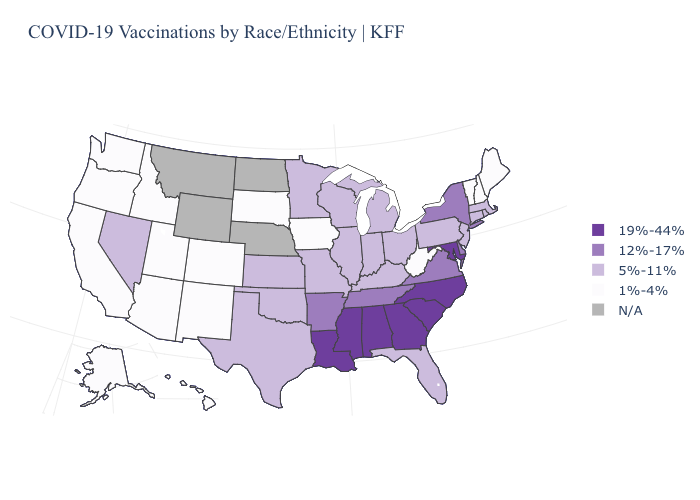What is the value of Washington?
Keep it brief. 1%-4%. What is the value of Colorado?
Concise answer only. 1%-4%. Among the states that border Iowa , does Minnesota have the lowest value?
Keep it brief. No. What is the value of Idaho?
Give a very brief answer. 1%-4%. Among the states that border Arkansas , does Missouri have the lowest value?
Write a very short answer. Yes. What is the lowest value in the Northeast?
Give a very brief answer. 1%-4%. Which states have the lowest value in the USA?
Keep it brief. Alaska, Arizona, California, Colorado, Hawaii, Idaho, Iowa, Maine, New Hampshire, New Mexico, Oregon, South Dakota, Utah, Vermont, Washington, West Virginia. Name the states that have a value in the range 1%-4%?
Short answer required. Alaska, Arizona, California, Colorado, Hawaii, Idaho, Iowa, Maine, New Hampshire, New Mexico, Oregon, South Dakota, Utah, Vermont, Washington, West Virginia. What is the value of Wisconsin?
Quick response, please. 5%-11%. What is the value of Virginia?
Quick response, please. 12%-17%. Which states have the lowest value in the USA?
Give a very brief answer. Alaska, Arizona, California, Colorado, Hawaii, Idaho, Iowa, Maine, New Hampshire, New Mexico, Oregon, South Dakota, Utah, Vermont, Washington, West Virginia. Name the states that have a value in the range 1%-4%?
Quick response, please. Alaska, Arizona, California, Colorado, Hawaii, Idaho, Iowa, Maine, New Hampshire, New Mexico, Oregon, South Dakota, Utah, Vermont, Washington, West Virginia. Name the states that have a value in the range 12%-17%?
Concise answer only. Arkansas, Delaware, New York, Tennessee, Virginia. What is the lowest value in the USA?
Answer briefly. 1%-4%. 